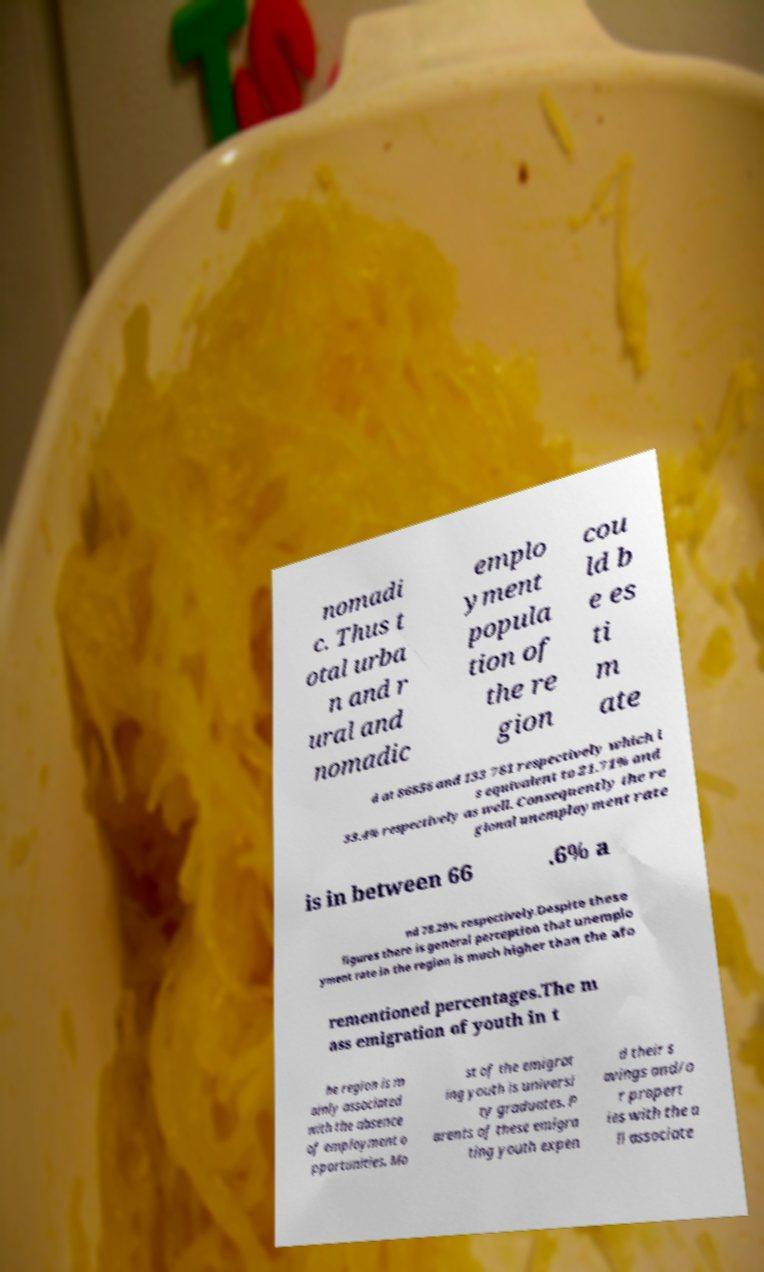Could you assist in decoding the text presented in this image and type it out clearly? nomadi c. Thus t otal urba n and r ural and nomadic emplo yment popula tion of the re gion cou ld b e es ti m ate d at 86856 and 133 781 respectively which i s equivalent to 21.71% and 33.4% respectively as well. Consequently the re gional unemployment rate is in between 66 .6% a nd 78.29% respectively.Despite these figures there is general perception that unemplo yment rate in the region is much higher than the afo rementioned percentages.The m ass emigration of youth in t he region is m ainly associated with the absence of employment o pportunities. Mo st of the emigrat ing youth is universi ty graduates. P arents of these emigra ting youth expen d their s avings and/o r propert ies with the a ll associate 